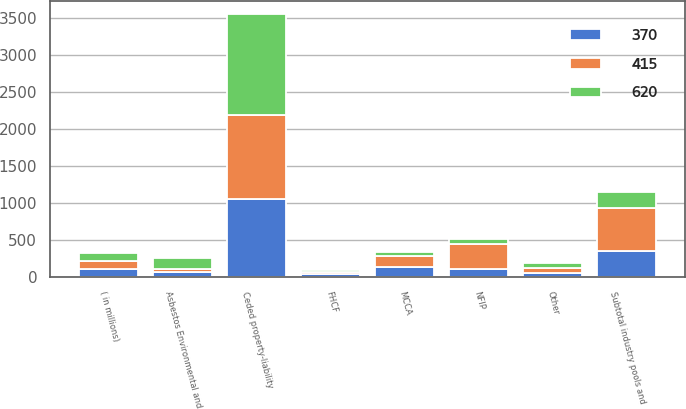Convert chart to OTSL. <chart><loc_0><loc_0><loc_500><loc_500><stacked_bar_chart><ecel><fcel>( in millions)<fcel>Ceded property-liability<fcel>FHCF<fcel>NFIP<fcel>MCCA<fcel>Other<fcel>Subtotal industry pools and<fcel>Asbestos Environmental and<nl><fcel>370<fcel>111<fcel>1056<fcel>47<fcel>111<fcel>133<fcel>59<fcel>350<fcel>65<nl><fcel>415<fcel>111<fcel>1139<fcel>28<fcel>344<fcel>148<fcel>60<fcel>580<fcel>40<nl><fcel>620<fcel>111<fcel>1356<fcel>22<fcel>65<fcel>60<fcel>72<fcel>219<fcel>151<nl></chart> 